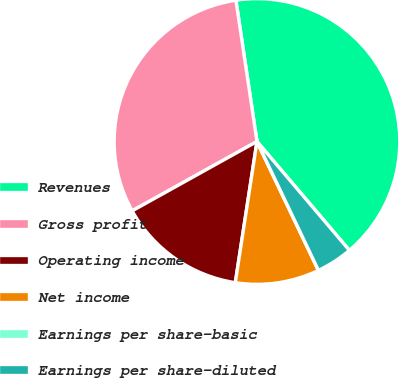<chart> <loc_0><loc_0><loc_500><loc_500><pie_chart><fcel>Revenues<fcel>Gross profit<fcel>Operating income<fcel>Net income<fcel>Earnings per share-basic<fcel>Earnings per share-diluted<nl><fcel>41.15%<fcel>30.72%<fcel>14.5%<fcel>9.51%<fcel>0.0%<fcel>4.12%<nl></chart> 